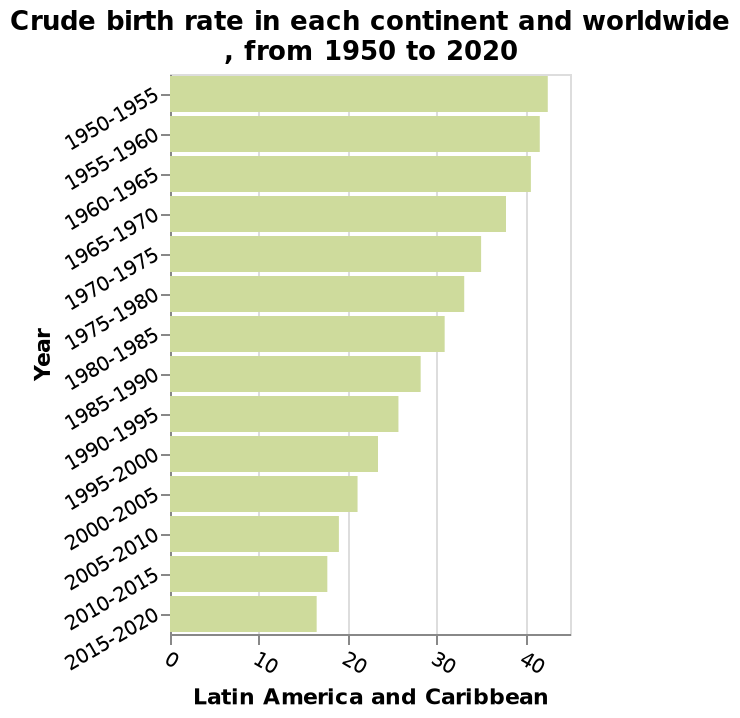<image>
What is the subject of the bar plot? The subject of the bar plot is the "Crude birth rate". What region does the chart focus on when it comes to crude births? The chart focuses on crude births within Latin America and the Caribbean. What is the variable plotted on the x-axis of the bar plot?  The variable plotted on the x-axis of the bar plot is "Latin America and Caribbean". Which continents are included in the bar plot? The bar plot includes data for all continents worldwide. 